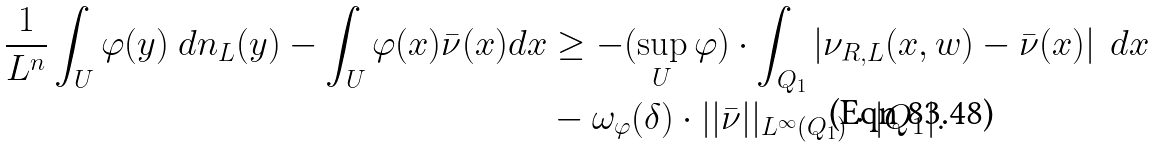Convert formula to latex. <formula><loc_0><loc_0><loc_500><loc_500>\frac { 1 } { L ^ { n } } \int _ { U } \varphi ( y ) \ d n _ { L } ( y ) - \int _ { U } \varphi ( x ) \bar { \nu } ( x ) d x & \geq - ( \sup _ { U } \varphi ) \cdot \int _ { Q _ { 1 } } \left | \nu _ { R , L } ( x , w ) - \bar { \nu } ( x ) \right | \ d x \\ & - \omega _ { \varphi } ( \delta ) \cdot | | \bar { \nu } | | _ { L ^ { \infty } ( Q _ { 1 } ) } \cdot | Q _ { 1 } | .</formula> 